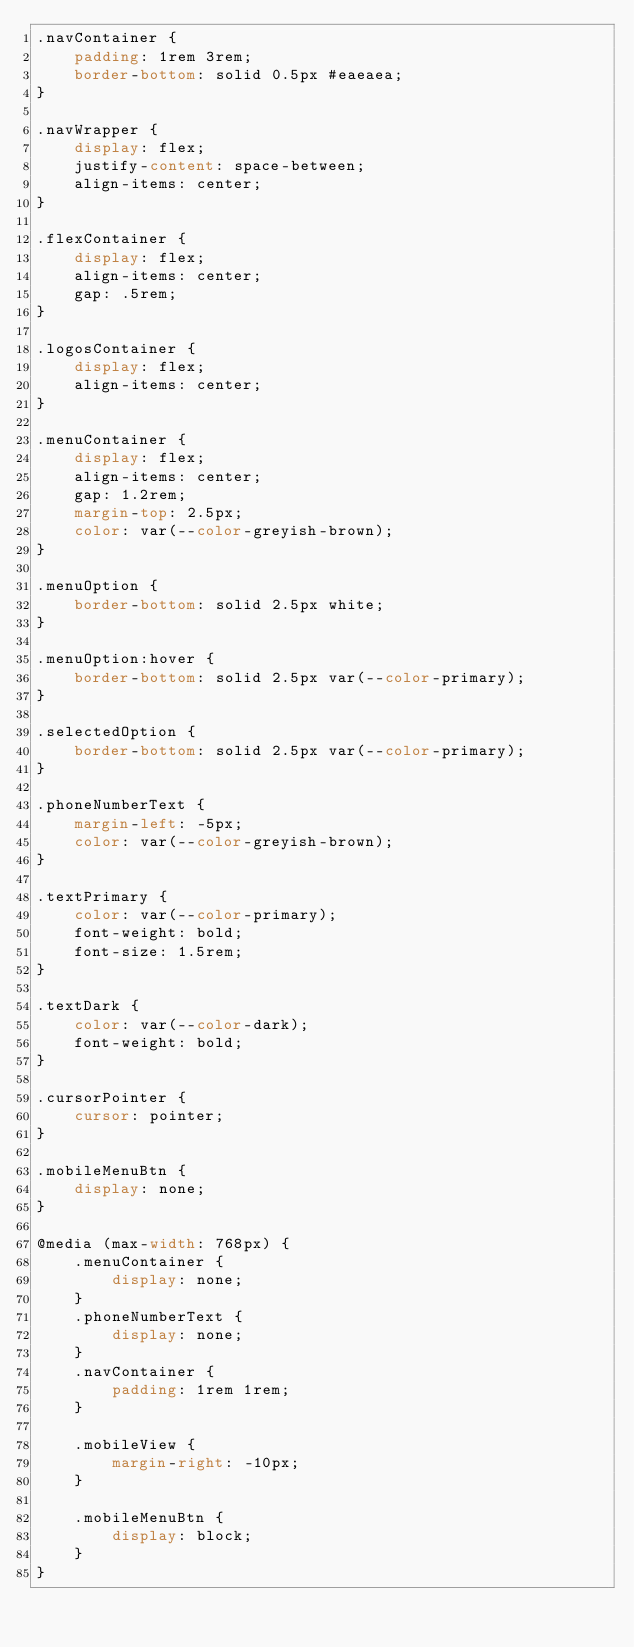<code> <loc_0><loc_0><loc_500><loc_500><_CSS_>.navContainer {
    padding: 1rem 3rem;
    border-bottom: solid 0.5px #eaeaea;
}

.navWrapper {
    display: flex;
    justify-content: space-between;
    align-items: center;
}

.flexContainer {
    display: flex;
    align-items: center;
    gap: .5rem;
}

.logosContainer {
    display: flex;
    align-items: center;
}

.menuContainer {
    display: flex;
    align-items: center;
    gap: 1.2rem;
    margin-top: 2.5px;
    color: var(--color-greyish-brown);
}

.menuOption {
    border-bottom: solid 2.5px white;
}

.menuOption:hover {
    border-bottom: solid 2.5px var(--color-primary);
}

.selectedOption {
    border-bottom: solid 2.5px var(--color-primary);
}

.phoneNumberText {
    margin-left: -5px;
    color: var(--color-greyish-brown);
}

.textPrimary {
    color: var(--color-primary);
    font-weight: bold;
    font-size: 1.5rem;
}

.textDark {
    color: var(--color-dark);
    font-weight: bold;
}

.cursorPointer {
    cursor: pointer;
}

.mobileMenuBtn {
    display: none;
}

@media (max-width: 768px) {
    .menuContainer {
        display: none;
    }
    .phoneNumberText {
        display: none;
    }
    .navContainer {
        padding: 1rem 1rem;
    }

    .mobileView {
        margin-right: -10px;
    }

    .mobileMenuBtn {
        display: block;
    }
}</code> 